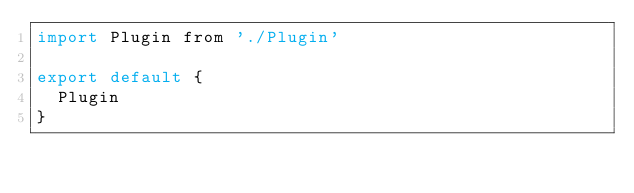Convert code to text. <code><loc_0><loc_0><loc_500><loc_500><_JavaScript_>import Plugin from './Plugin'

export default {
  Plugin
}</code> 